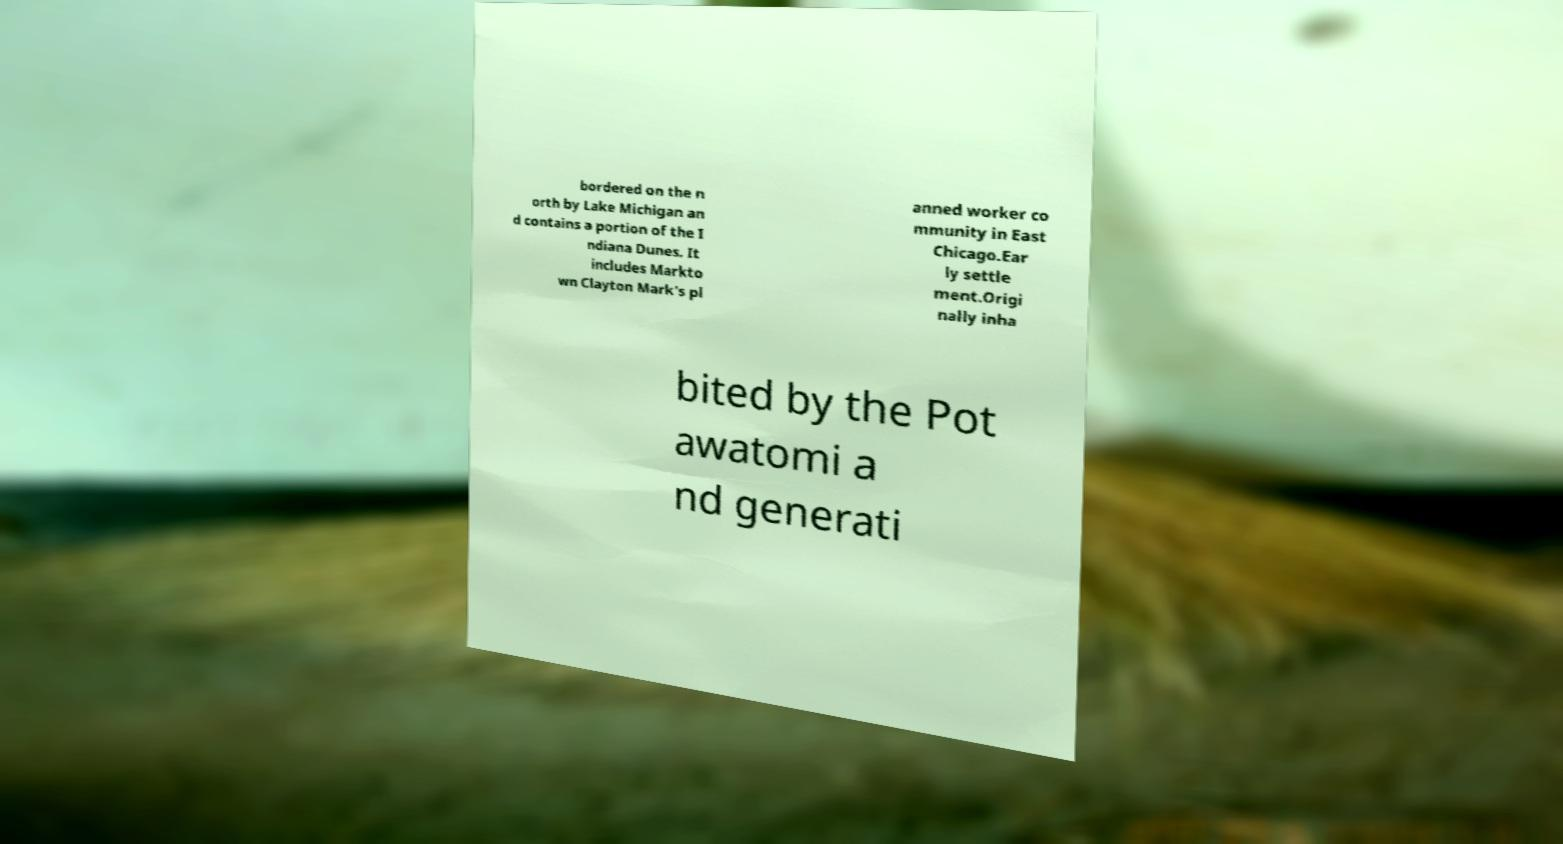For documentation purposes, I need the text within this image transcribed. Could you provide that? bordered on the n orth by Lake Michigan an d contains a portion of the I ndiana Dunes. It includes Markto wn Clayton Mark's pl anned worker co mmunity in East Chicago.Ear ly settle ment.Origi nally inha bited by the Pot awatomi a nd generati 